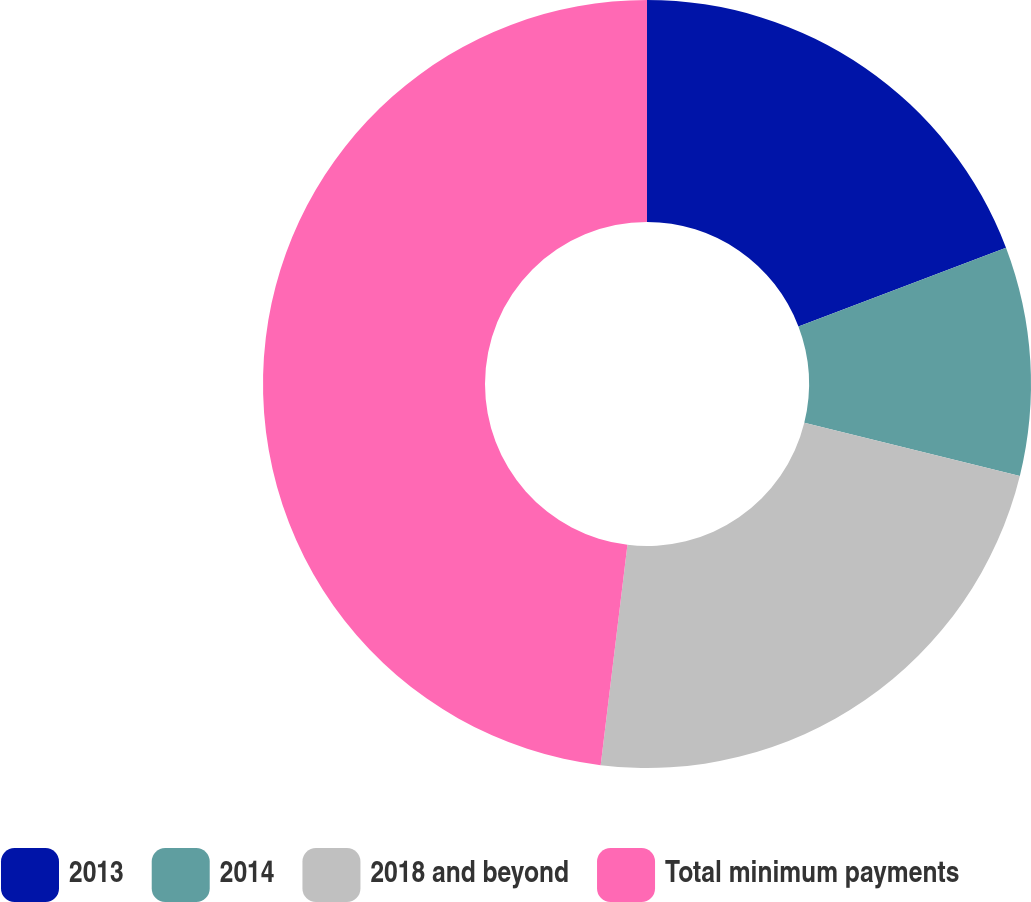Convert chart. <chart><loc_0><loc_0><loc_500><loc_500><pie_chart><fcel>2013<fcel>2014<fcel>2018 and beyond<fcel>Total minimum payments<nl><fcel>19.23%<fcel>9.62%<fcel>23.08%<fcel>48.08%<nl></chart> 